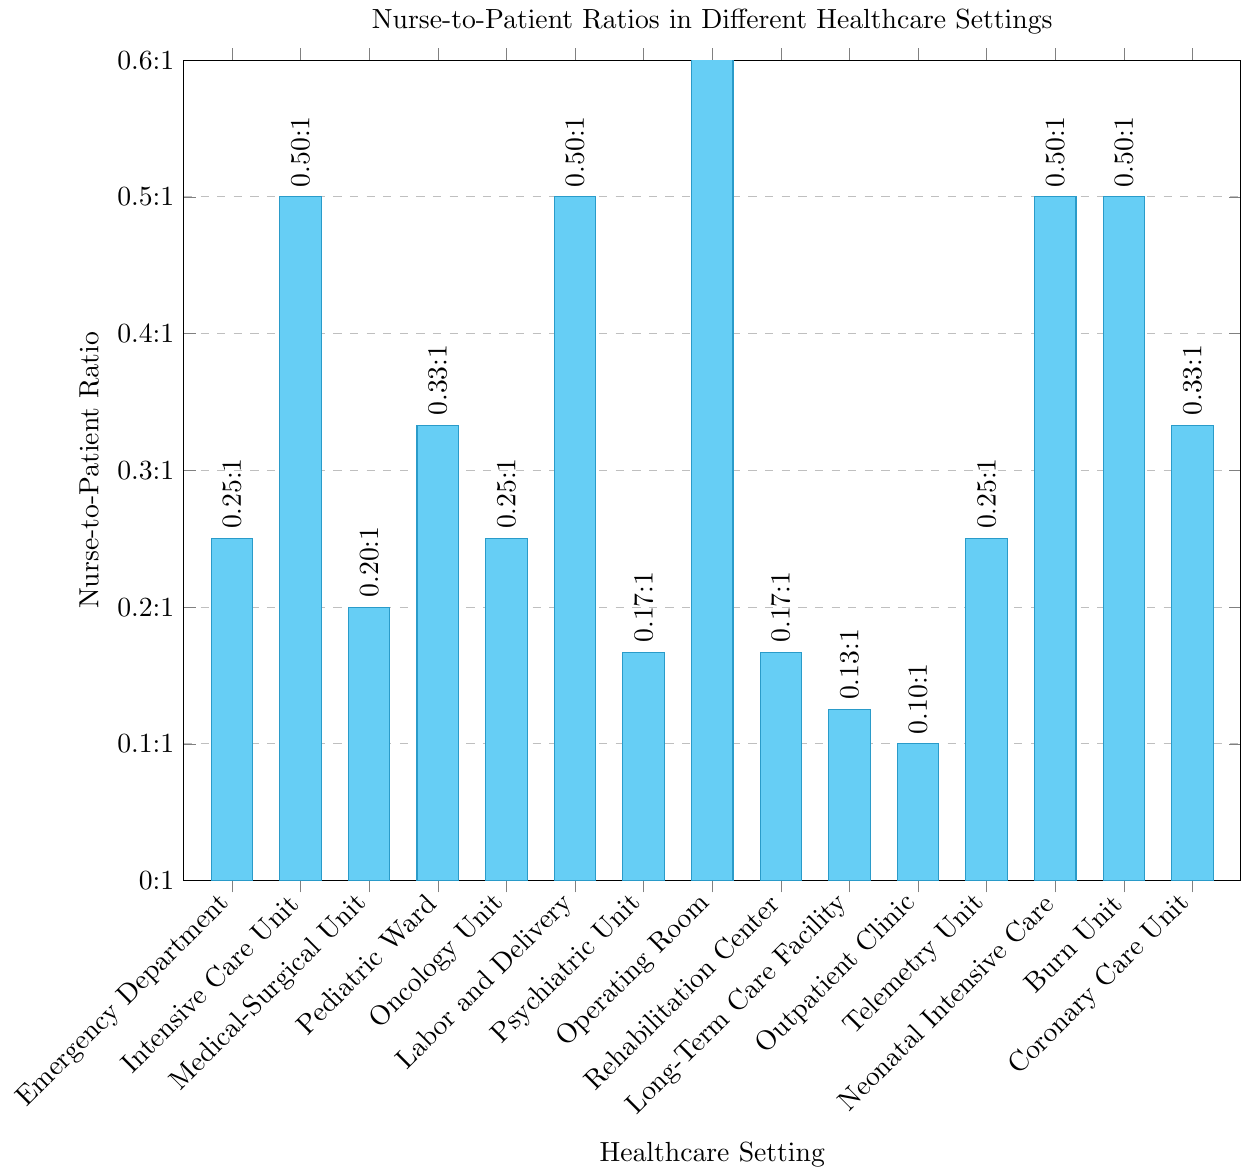Which healthcare setting has the highest nurse-to-patient ratio? Locate the bar with the maximum height and find the corresponding healthcare setting on the x-axis. The Operating Room has the highest bar.
Answer: Operating Room Which healthcare setting has the lowest nurse-to-patient ratio? Locate the bar with the lowest height and find the corresponding healthcare setting on the x-axis. The Outpatient Clinic has the lowest bar.
Answer: Outpatient Clinic Which healthcare settings have a nurse-to-patient ratio of 1:2? Identify the bars that reach the height corresponding to 1:2 and find the associated healthcare settings on the x-axis. Intensive Care Unit, Labor and Delivery, Neonatal Intensive Care, and Burn Unit have this ratio.
Answer: Intensive Care Unit, Labor and Delivery, Neonatal Intensive Care, Burn Unit What is the difference in nurse-to-patient ratio between the Psychiatric Unit and the Medical-Surgical Unit? Find the values for Psychiatric Unit (1:6) and Medical-Surgical Unit (1:5). Calculate the difference: (1/6) - (1/5) = 0.0333 (approx.)
Answer: 0.0333 How many healthcare settings have a nurse-to-patient ratio greater than 1:4? Count the bars that are taller than the height corresponding to 1:4. Rehabilitation Center, Long-Term Care Facility, and Outpatient Clinic have a higher ratio.
Answer: 3 What is the average nurse-to-patient ratio across all healthcare settings? Convert ratios to decimal form: [(1/4)+(1/2)+(1/5)+(1/3)+(1/4)+(1/2)+(1/6)+(1/1)+(1/6)+(1/8)+(1/10)+(1/4)+(1/2)+(1/2)+(1/3)]; sum these values and divide by 15.
Answer: 0.3367 (approx.) Is the nurse-to-patient ratio of the Emergency Department higher or lower than that of the Telemetry Unit? Compare the height of the bar for Emergency Department (1:4) with that of the Telemetry Unit (1:4). Both are the same.
Answer: Equal Which healthcare settings have a nurse-to-patient ratio equal to the Emergency Department? Find the bars with the same height as the Emergency Department (1:4). Oncology Unit and Telemetry Unit match this ratio.
Answer: Oncology Unit, Telemetry Unit What is the combined nurse-to-patient ratio of the Neonatal Intensive Care and the Coronary Care Unit? Add the ratios of Neonatal Intensive Care (1:2) and Coronary Care Unit (1:3): (1/2) + (1/3) = 0.5 + 0.3333 = 0.8333
Answer: 0.8333 What percentage of healthcare settings have a nurse-to-patient ratio of 1:2? Identify healthcare settings with a ratio of 1:2 (Intensive Care Unit, Labor and Delivery, Neonatal Intensive Care, Burn Unit). There are 4 out of 15 total healthcare settings, calculate the percentage: (4/15) * 100 = 26.67%
Answer: 26.67% 